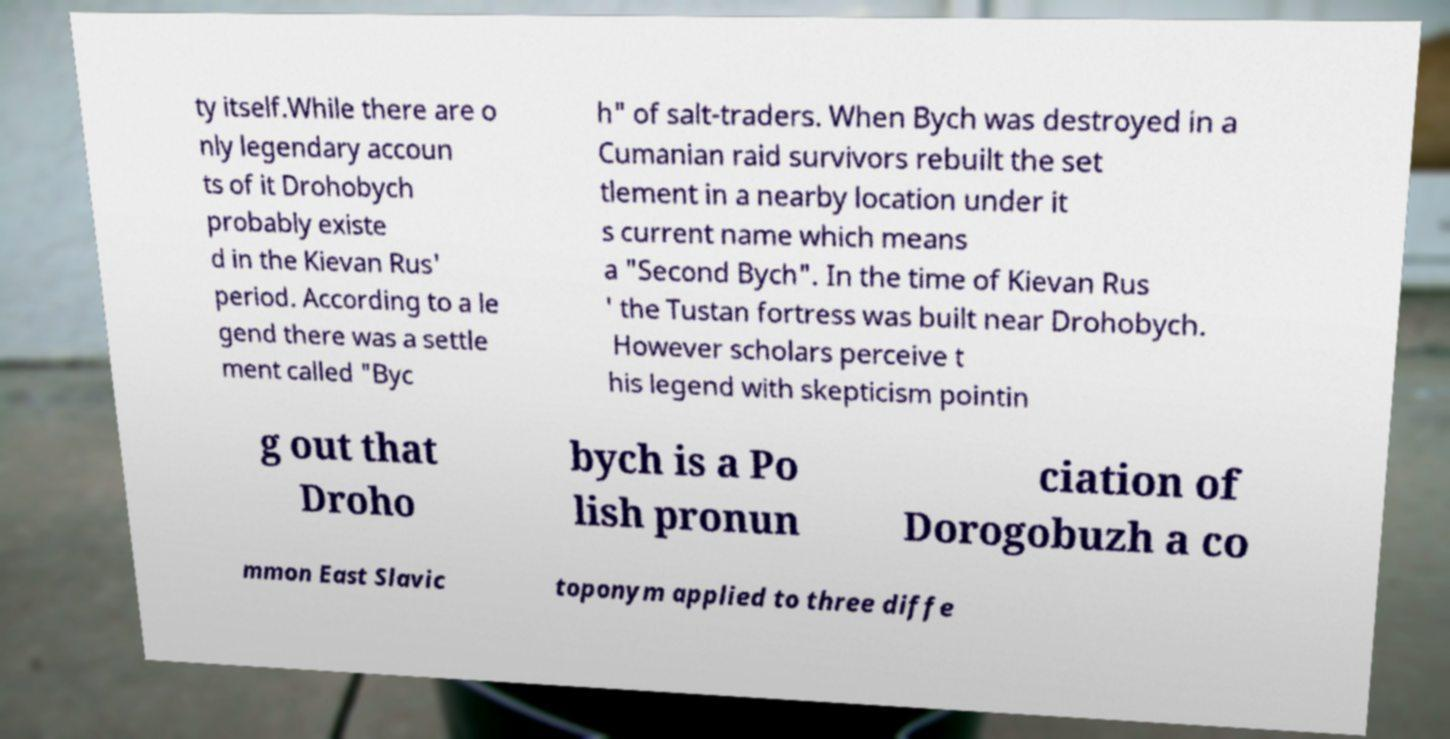I need the written content from this picture converted into text. Can you do that? ty itself.While there are o nly legendary accoun ts of it Drohobych probably existe d in the Kievan Rus' period. According to a le gend there was a settle ment called "Byc h" of salt-traders. When Bych was destroyed in a Cumanian raid survivors rebuilt the set tlement in a nearby location under it s current name which means a "Second Bych". In the time of Kievan Rus ' the Tustan fortress was built near Drohobych. However scholars perceive t his legend with skepticism pointin g out that Droho bych is a Po lish pronun ciation of Dorogobuzh a co mmon East Slavic toponym applied to three diffe 